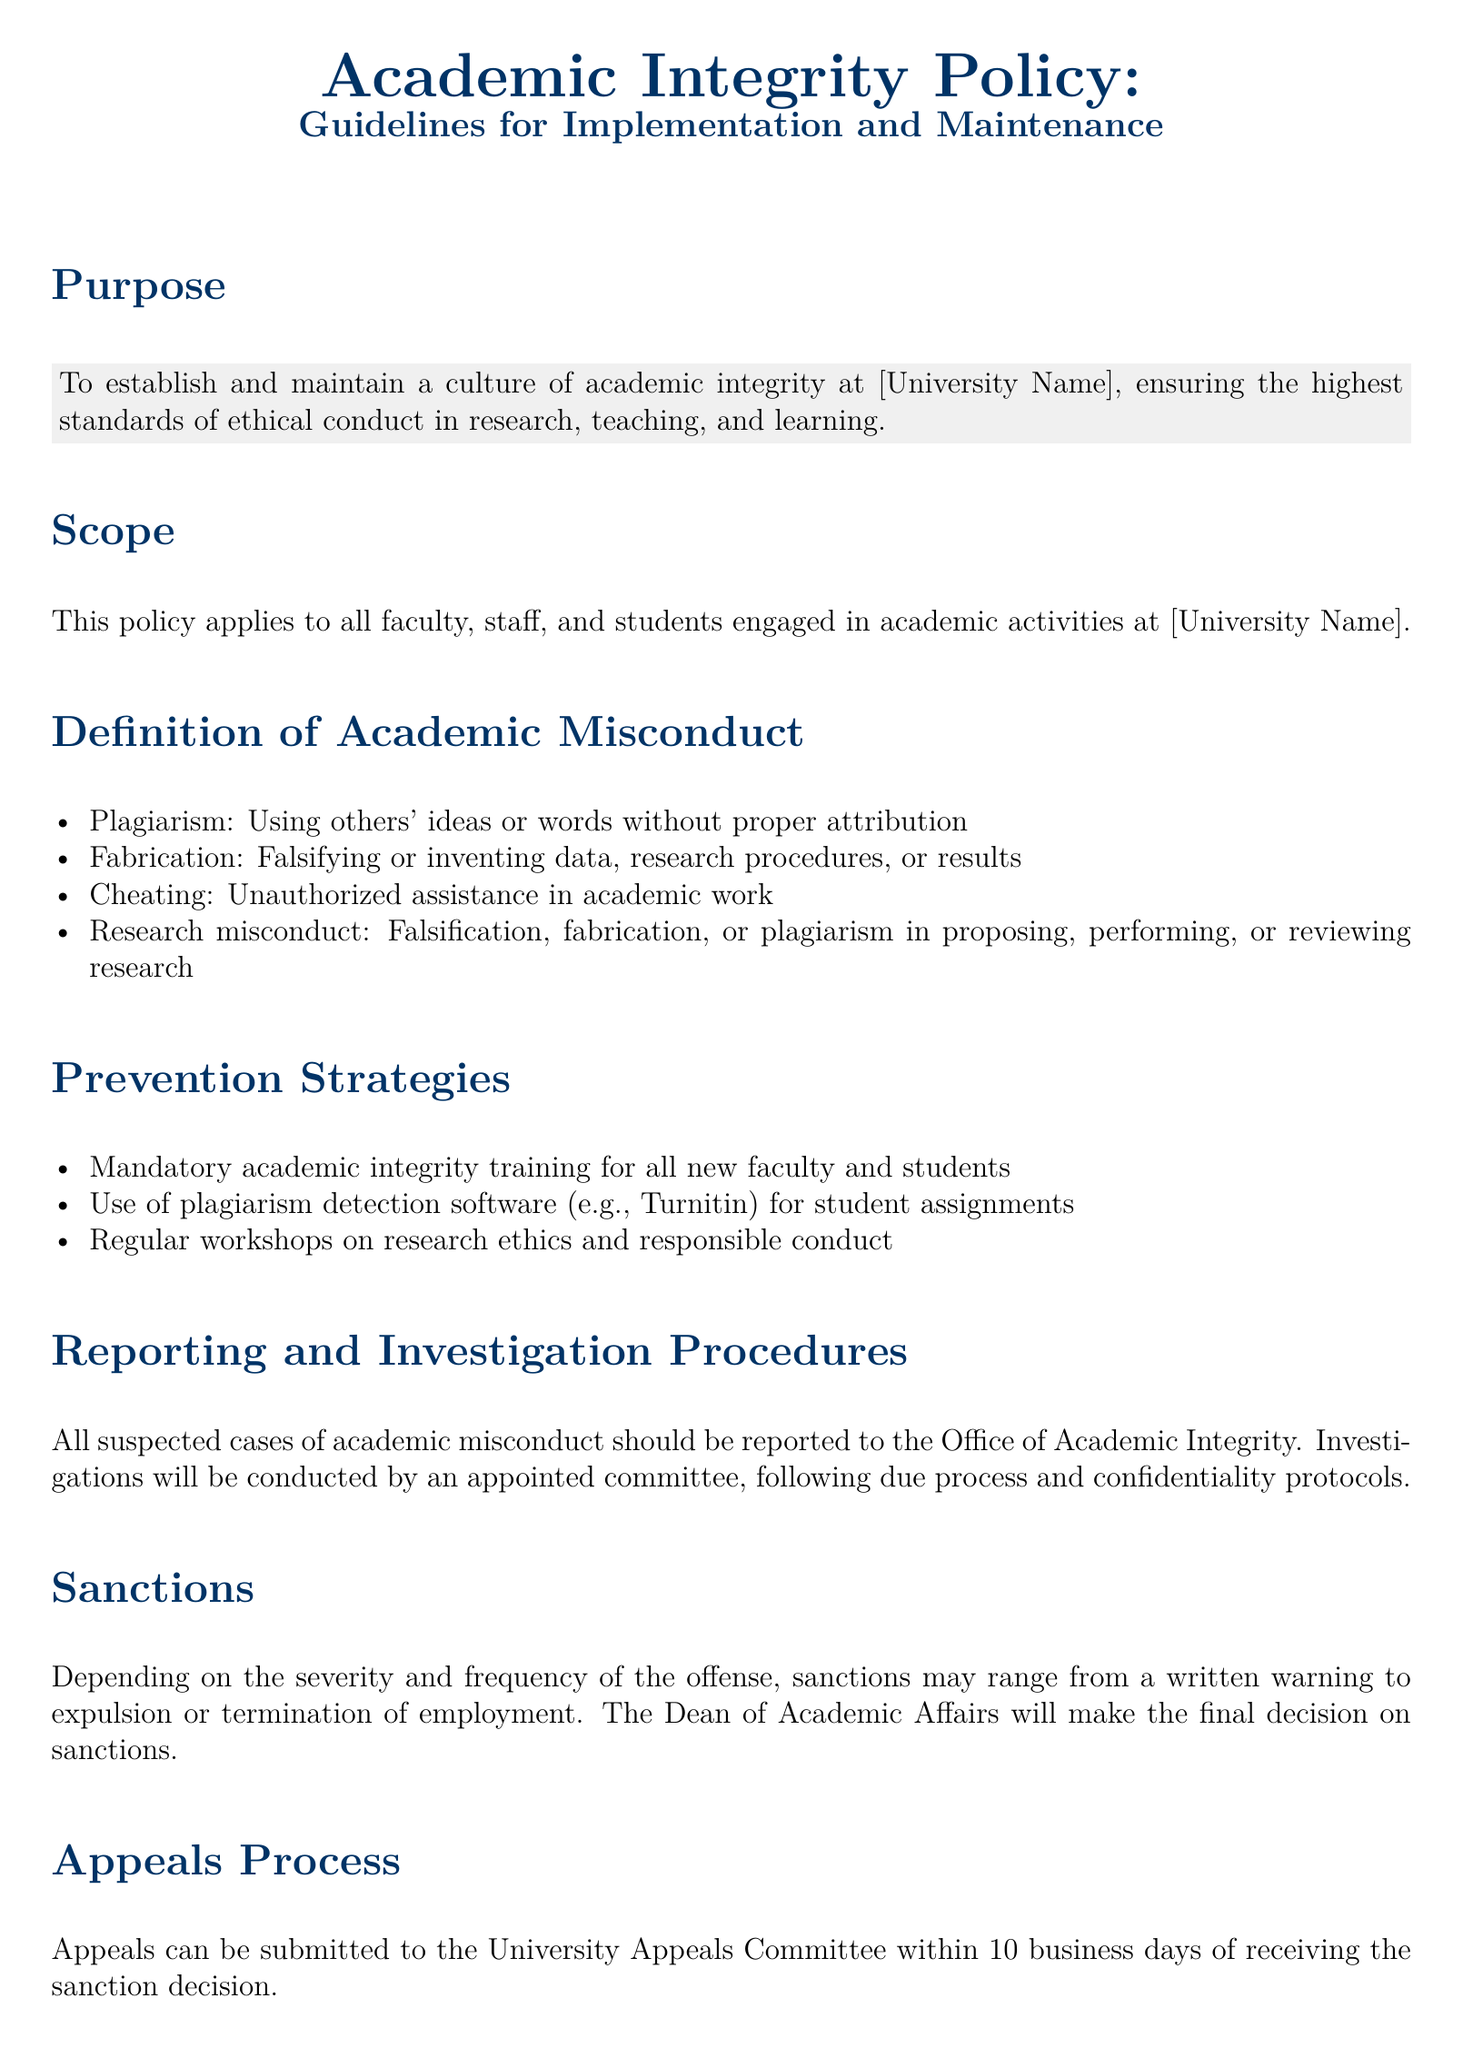What is the purpose of the policy? The purpose is to establish and maintain a culture of academic integrity at the university, ensuring high standards of ethical conduct.
Answer: To establish and maintain a culture of academic integrity Who does the policy apply to? The policy applies to all individuals engaged in academic activities at the university.
Answer: Faculty, staff, and students What is defined as plagiarism? Plagiarism is using others' ideas or words without proper attribution.
Answer: Using others' ideas or words without proper attribution What strategies are mentioned for prevention? Mandatory academic integrity training for all new faculty and students is one of the strategies.
Answer: Mandatory academic integrity training What is the appeals submission timeframe? Appeals must be submitted within 10 business days of the sanction decision.
Answer: 10 business days What committee conducts investigations of misconduct? An appointed committee conducts investigations.
Answer: Appointed committee What can be a possible sanction for academic misconduct? Sanctions may range from a written warning to expulsion or termination of employment.
Answer: Written warning to expulsion or termination How often will the policy be reviewed? The policy will be reviewed annually.
Answer: Annually 